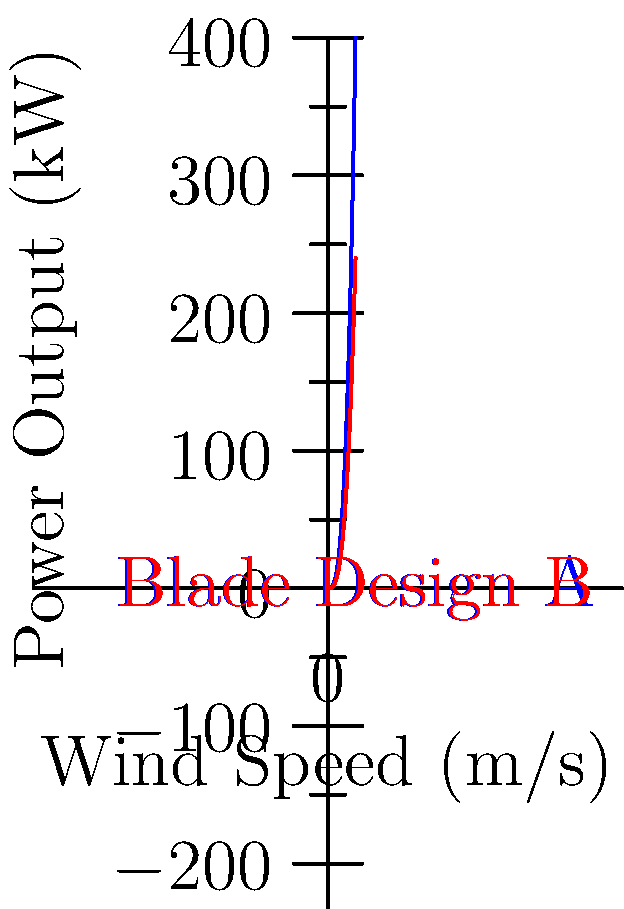As a community leader in Seke, Zimbabwe, you're considering implementing wind turbines for sustainable energy. The graph shows the power output of two different wind turbine blade designs (A and B) as a function of wind speed. If the average wind speed in your area is 12 m/s, what is the difference in power output between blade designs A and B? To solve this problem, we'll follow these steps:

1. Identify the power output equation for each blade design:
   Design A: $P_A = 0.05v^3$
   Design B: $P_B = 0.03v^3$
   Where $P$ is power in kW and $v$ is wind speed in m/s.

2. Calculate the power output for Design A at 12 m/s:
   $P_A = 0.05 * (12)^3 = 0.05 * 1728 = 86.4$ kW

3. Calculate the power output for Design B at 12 m/s:
   $P_B = 0.03 * (12)^3 = 0.03 * 1728 = 51.84$ kW

4. Find the difference in power output:
   Difference = $P_A - P_B = 86.4 - 51.84 = 34.56$ kW

The difference in power output between blade designs A and B at 12 m/s wind speed is 34.56 kW.
Answer: 34.56 kW 